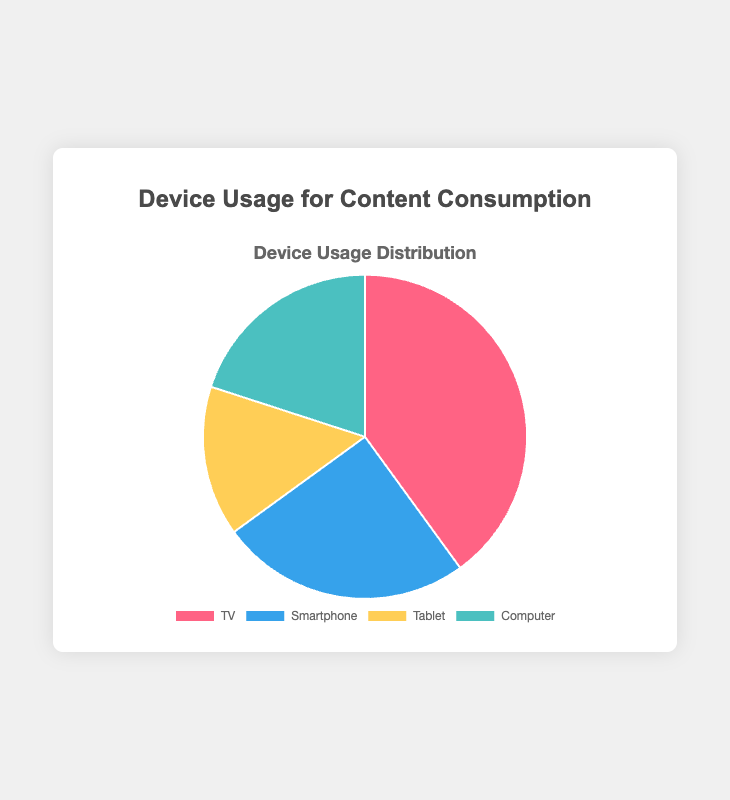Which device has the highest usage percentage? The pie chart shows four devices with their respective usage percentages. The highest percentage is represented by TV with 40%.
Answer: TV Which two devices together constitute half of the total device usage? The pie chart lists the usage percentages as TV 40%, Smartphone 25%, Tablet 15%, Computer 20%. Adding TV (40%) and Computer (20%) gives 60% which is more than half. The correct combination is TV (40%) and Smartphone (25%), totaling 65%.
Answer: TV and Smartphone Which device is used more for content consumption, tablets or computers? The pie chart indicates that tablet usage is 15% while computer usage is 20%. Since 20% is greater than 15%, computers are used more.
Answer: Computer What is the percentage difference between the most and least used devices? The highest usage percentage is for TV at 40% and the lowest is for Tablets at 15%. The difference is 40% - 15% = 25%.
Answer: 25% If we combine the usage percentages of smartphones and tablets, what percentage do they cover together? The pie chart shows that smartphones are used 25% and tablets 15%, summing these values gives 25% + 15% = 40%.
Answer: 40% How does the usage of computers compare to smartphones in terms of percentage? The pie chart reveals that smartphones have a usage percentage of 25% while computers have 20%. Smartphones usage percentage is higher by 5%.
Answer: Smartphones usage is higher by 5% Which device usage is second highest? The pie chart shows the usage values for devices; the highest is TV with 40%. The second highest is the smartphone at 25%.
Answer: Smartphone How much more is the TV's usage compared to the computer's usage? The pie chart shows TV usage at 40% and computer usage at 20%. The difference is 40% - 20% = 20%.
Answer: 20% Which devices have a combined usage percentage equal to that of TV? The pie chart has TV at 40%. The combined usage of Computer (20%) and Smartphones (25%) is 20% + 25% = 45%, which is more. The combination of Smartphones (25%) and Tablets (15%) is 25% + 15% = 40%, which equals TV.
Answer: Smartphones and Tablets What proportion of content consumption is not done through TV? The pie chart shows that TV usage is 40%. Therefore, the proportion not through TV is 100% - 40% = 60%.
Answer: 60% 